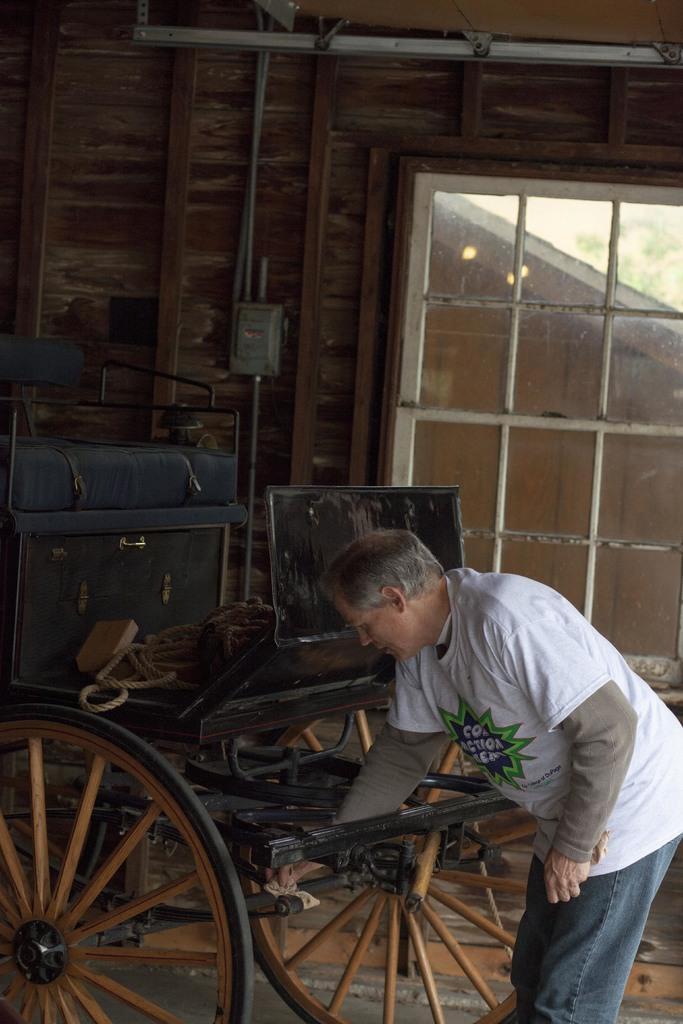Describe this image in one or two sentences. In this picture we can see a man, cart, window, wall, rope, lights, some objects and in the background we can see leaves. 